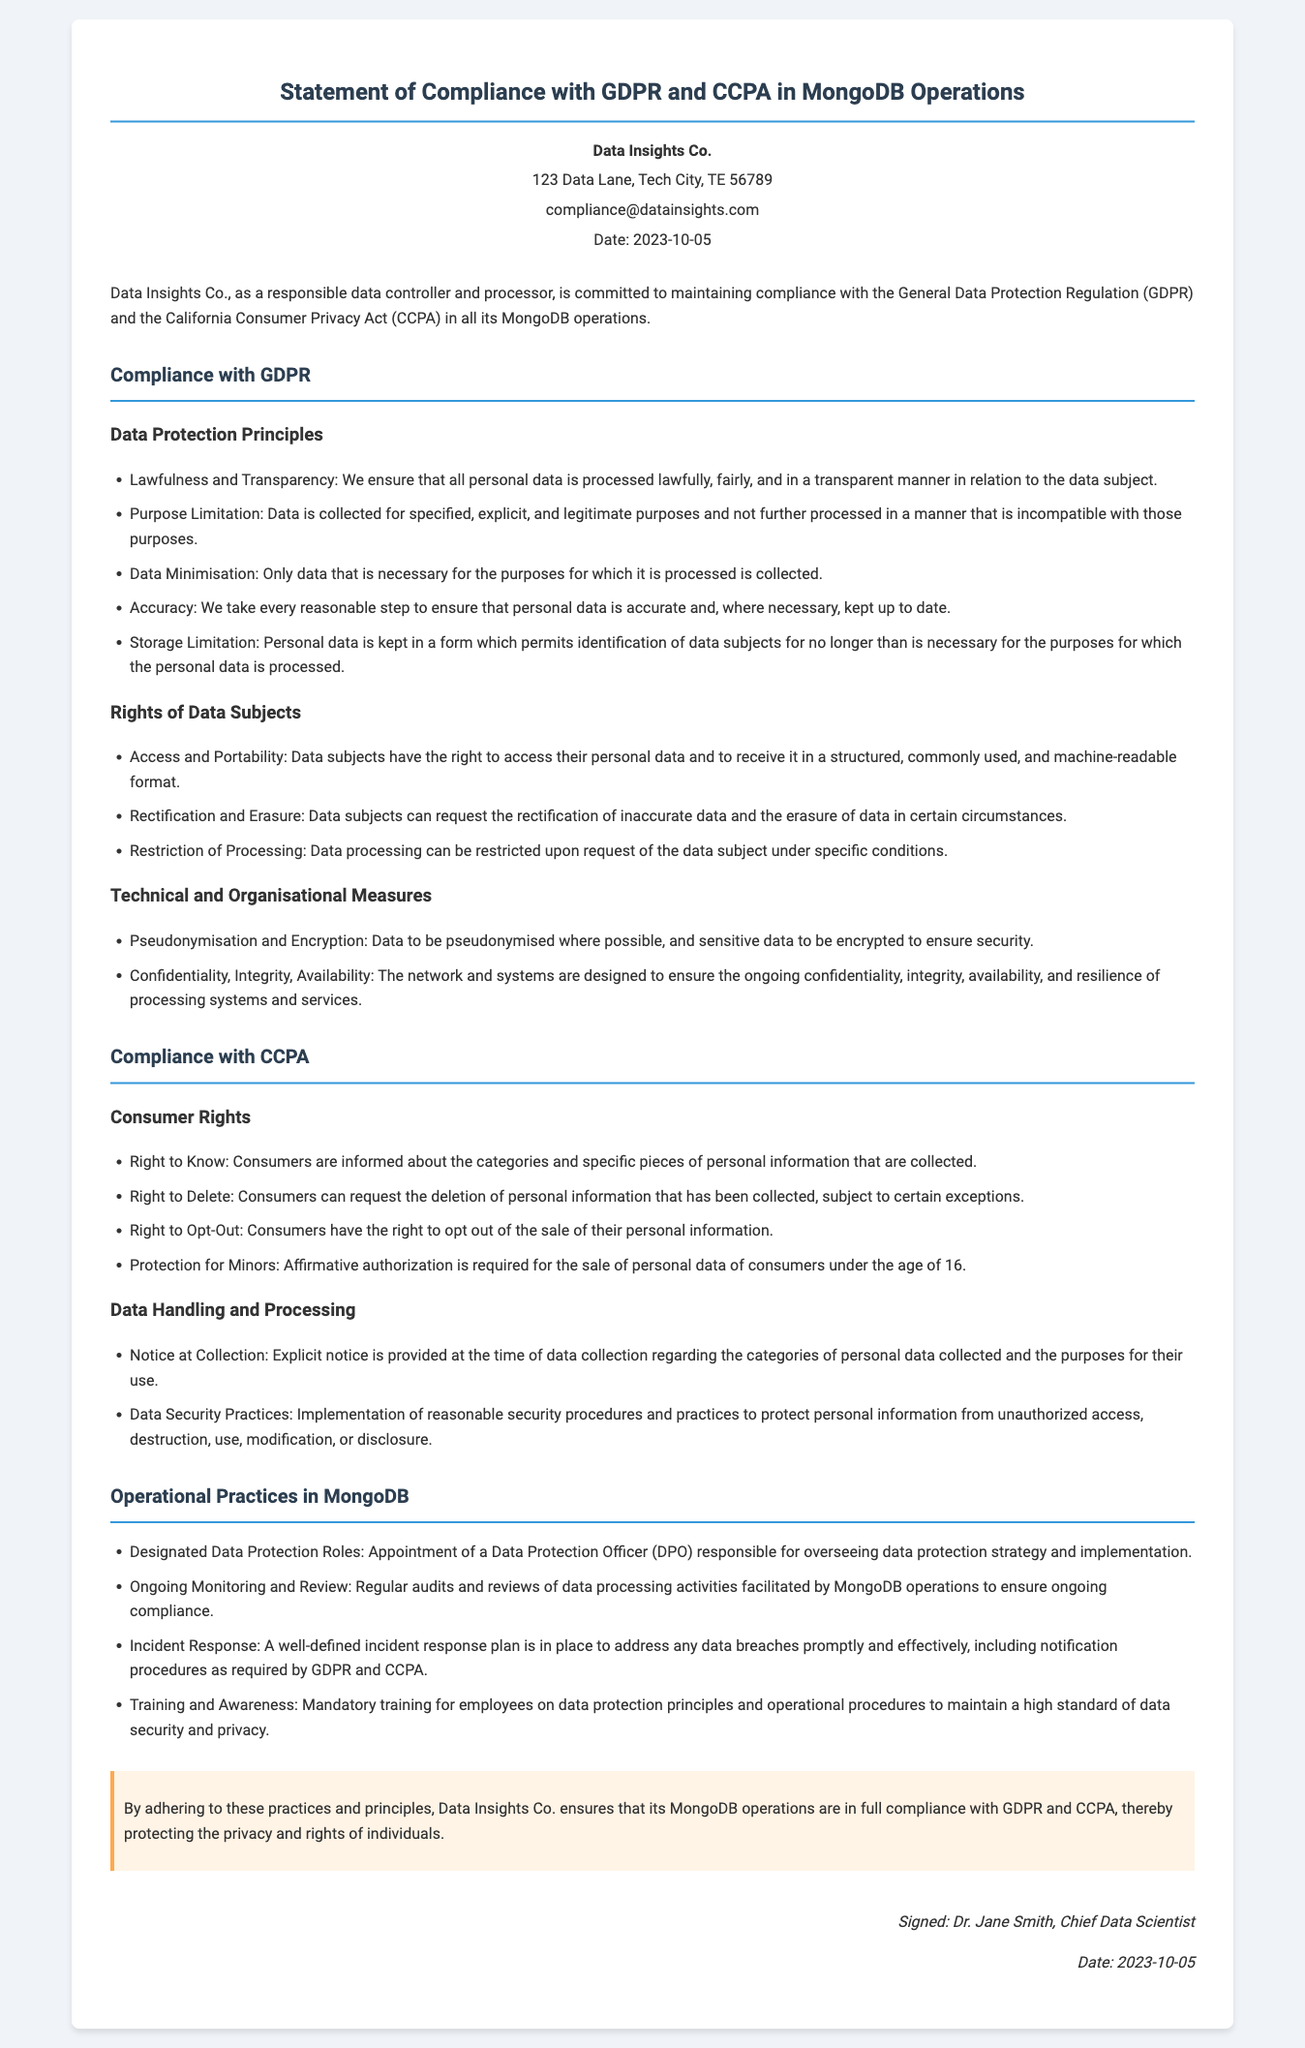What is the name of the company? The company name is mentioned in the header section of the document.
Answer: Data Insights Co What is the date of the declaration? The date is specified in the header section of the document.
Answer: 2023-10-05 Who signed the document? The name of the person who signed is included in the signature section of the document.
Answer: Dr. Jane Smith What is the primary regulation mentioned for compliance? The main regulatory framework is explicitly stated in the introduction section of the document.
Answer: GDPR What is the right of data subjects related to data access? This right is described under the Rights of Data Subjects subsection in the document.
Answer: Access and Portability How many consumer rights are listed under CCPA compliance? The rights are listed in the Compliance with CCPA section, which provides a specific count.
Answer: Four What role is designated for overseeing data protection strategy? The role responsible for this task is clearly identified in the Operational Practices in MongoDB section.
Answer: Data Protection Officer (DPO) What type of security measure is mentioned for sensitive data? This measure is indicated under Technical and Organisational Measures in the document.
Answer: Encryption How often are audits and reviews conducted? The frequency of these audits is implied within the description of ongoing monitoring and review in the Operational Practices in MongoDB.
Answer: Regular 